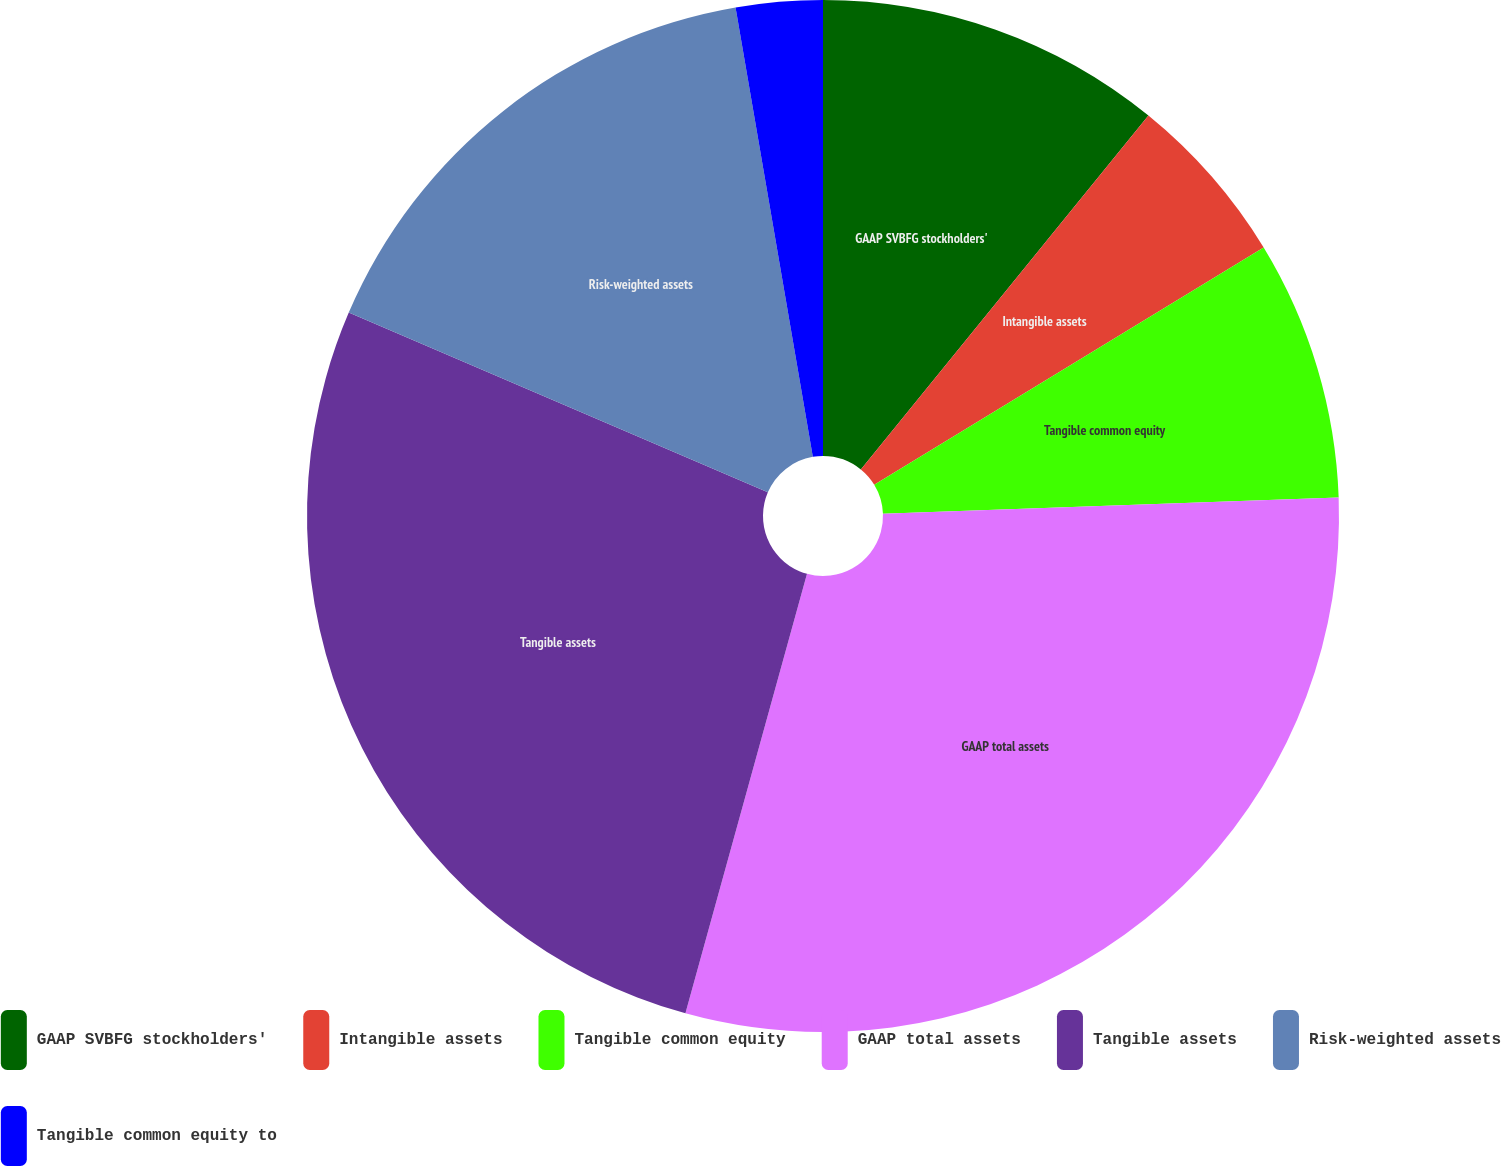<chart> <loc_0><loc_0><loc_500><loc_500><pie_chart><fcel>GAAP SVBFG stockholders'<fcel>Intangible assets<fcel>Tangible common equity<fcel>GAAP total assets<fcel>Tangible assets<fcel>Risk-weighted assets<fcel>Tangible common equity to<nl><fcel>10.86%<fcel>5.43%<fcel>8.14%<fcel>29.86%<fcel>27.15%<fcel>15.84%<fcel>2.71%<nl></chart> 